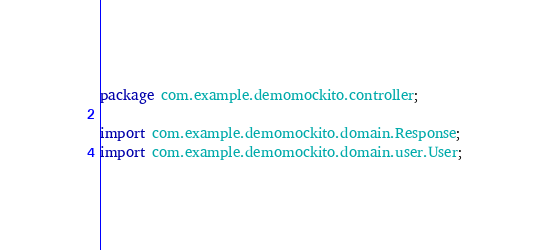Convert code to text. <code><loc_0><loc_0><loc_500><loc_500><_Java_>package com.example.demomockito.controller;

import com.example.demomockito.domain.Response;
import com.example.demomockito.domain.user.User;</code> 